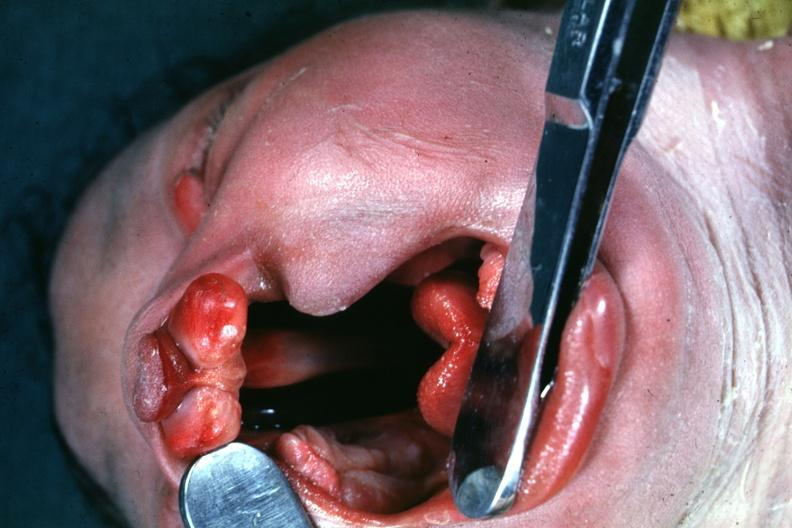how is head tilted with mouth opened to show large defect very illustration of this lesion?
Answer the question using a single word or phrase. Good 